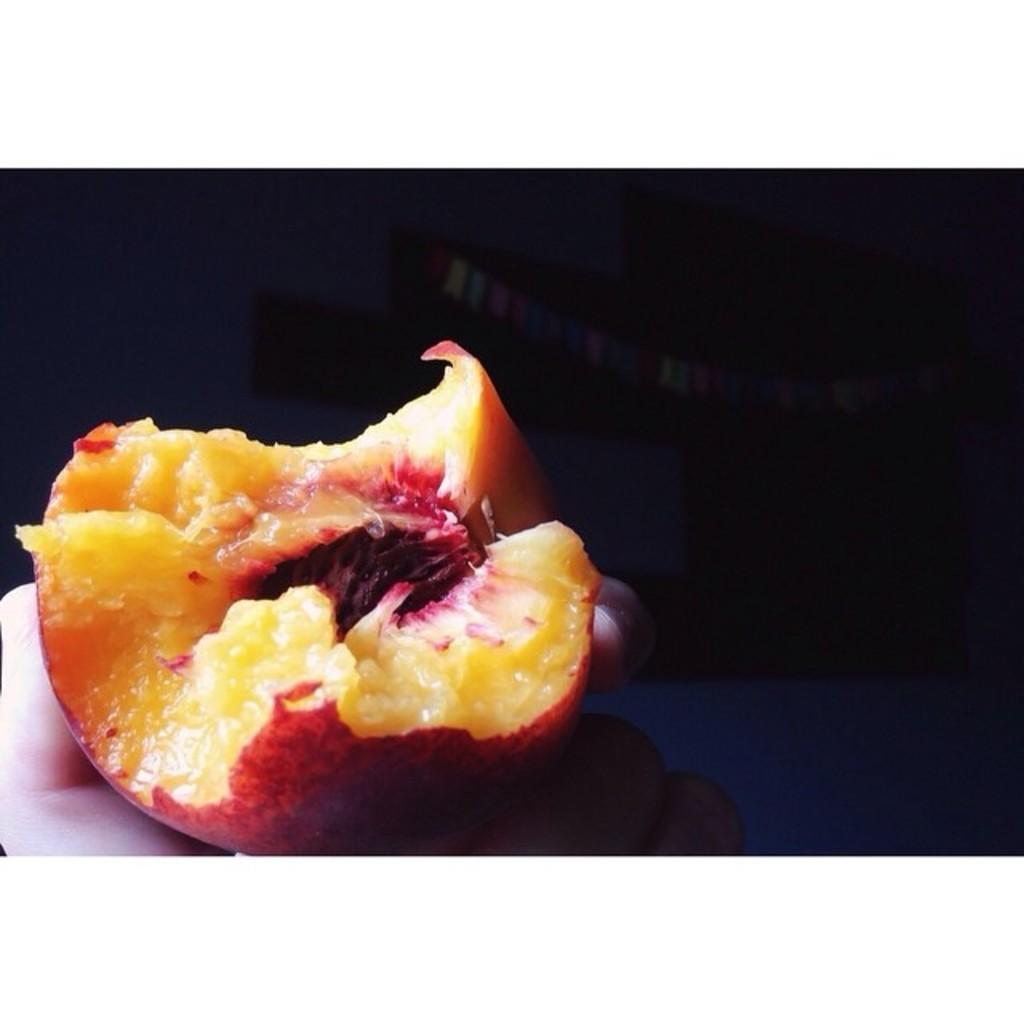What is the main subject of the image? The main subject of the image is a fruit. How is the fruit being held in the image? The fruit is being held by a hand. What can be observed about the background of the image? The background of the image is dark. How many sheep are visible on the sidewalk in the image? There are no sheep or sidewalk present in the image; it features a fruit being held by a hand against a dark background. 